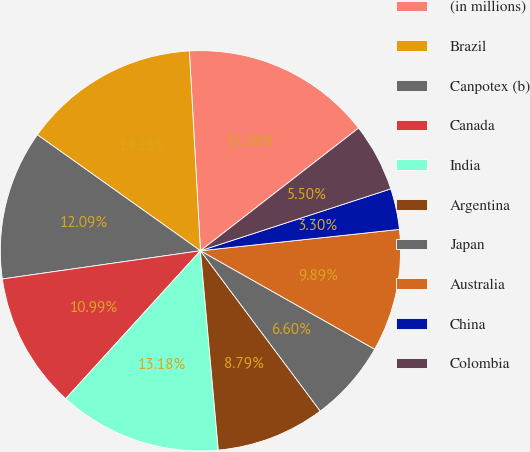Convert chart. <chart><loc_0><loc_0><loc_500><loc_500><pie_chart><fcel>(in millions)<fcel>Brazil<fcel>Canpotex (b)<fcel>Canada<fcel>India<fcel>Argentina<fcel>Japan<fcel>Australia<fcel>China<fcel>Colombia<nl><fcel>15.38%<fcel>14.28%<fcel>12.09%<fcel>10.99%<fcel>13.18%<fcel>8.79%<fcel>6.6%<fcel>9.89%<fcel>3.3%<fcel>5.5%<nl></chart> 